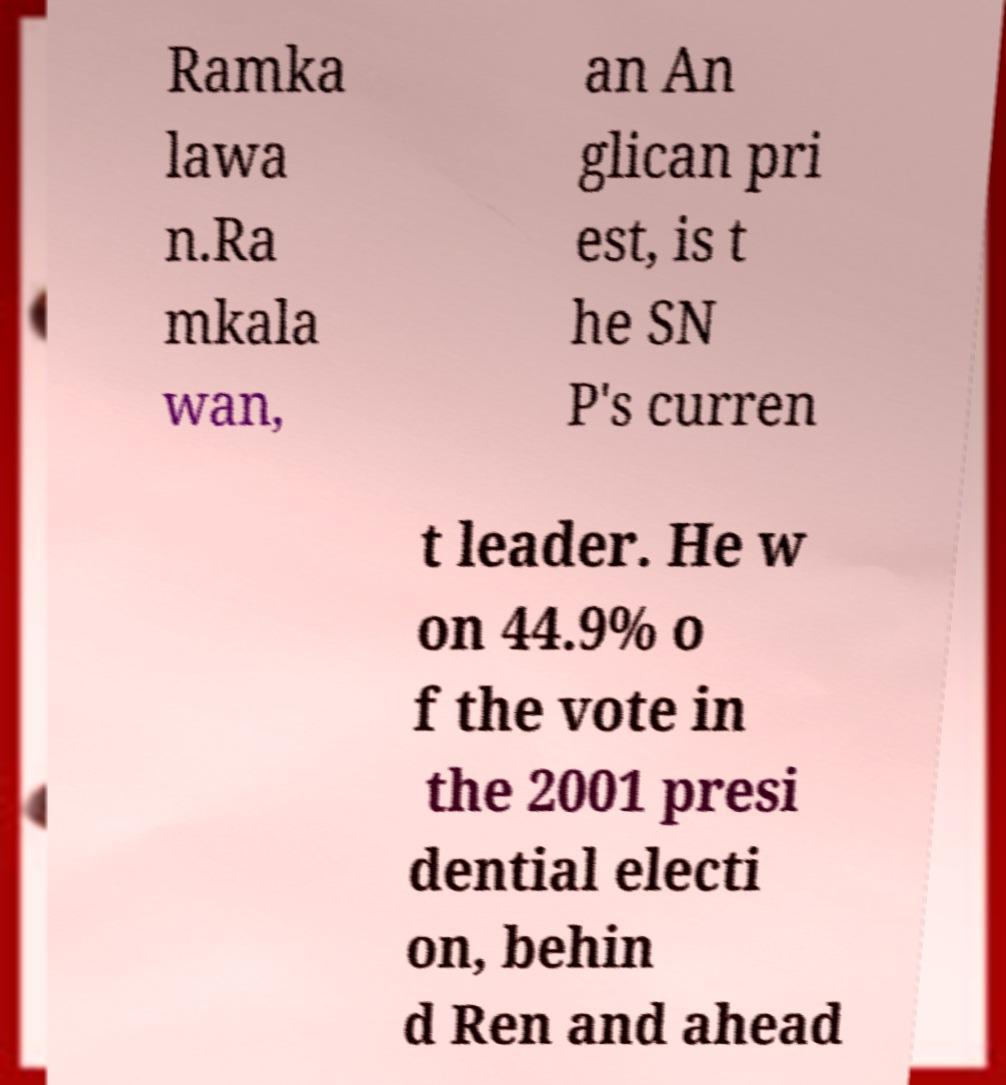Please read and relay the text visible in this image. What does it say? Ramka lawa n.Ra mkala wan, an An glican pri est, is t he SN P's curren t leader. He w on 44.9% o f the vote in the 2001 presi dential electi on, behin d Ren and ahead 